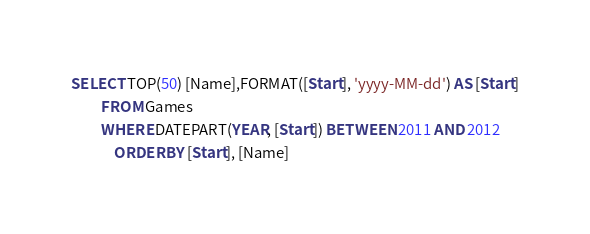Convert code to text. <code><loc_0><loc_0><loc_500><loc_500><_SQL_>SELECT TOP(50) [Name],FORMAT([Start], 'yyyy-MM-dd') AS [Start]
	     FROM Games
	     WHERE DATEPART(YEAR, [Start]) BETWEEN 2011 AND 2012
      	     ORDER BY [Start], [Name]</code> 